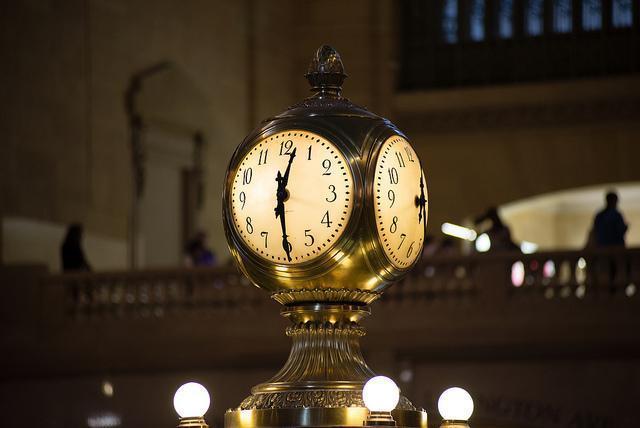How many round white lights are beneath the clocks?
Give a very brief answer. 3. How many clocks can you see?
Give a very brief answer. 2. 